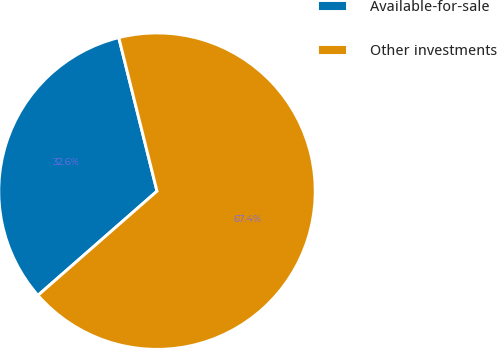Convert chart. <chart><loc_0><loc_0><loc_500><loc_500><pie_chart><fcel>Available-for-sale<fcel>Other investments<nl><fcel>32.56%<fcel>67.44%<nl></chart> 